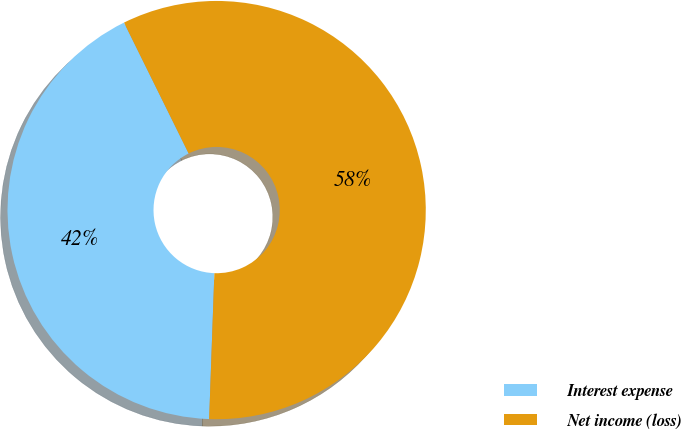Convert chart to OTSL. <chart><loc_0><loc_0><loc_500><loc_500><pie_chart><fcel>Interest expense<fcel>Net income (loss)<nl><fcel>42.13%<fcel>57.87%<nl></chart> 